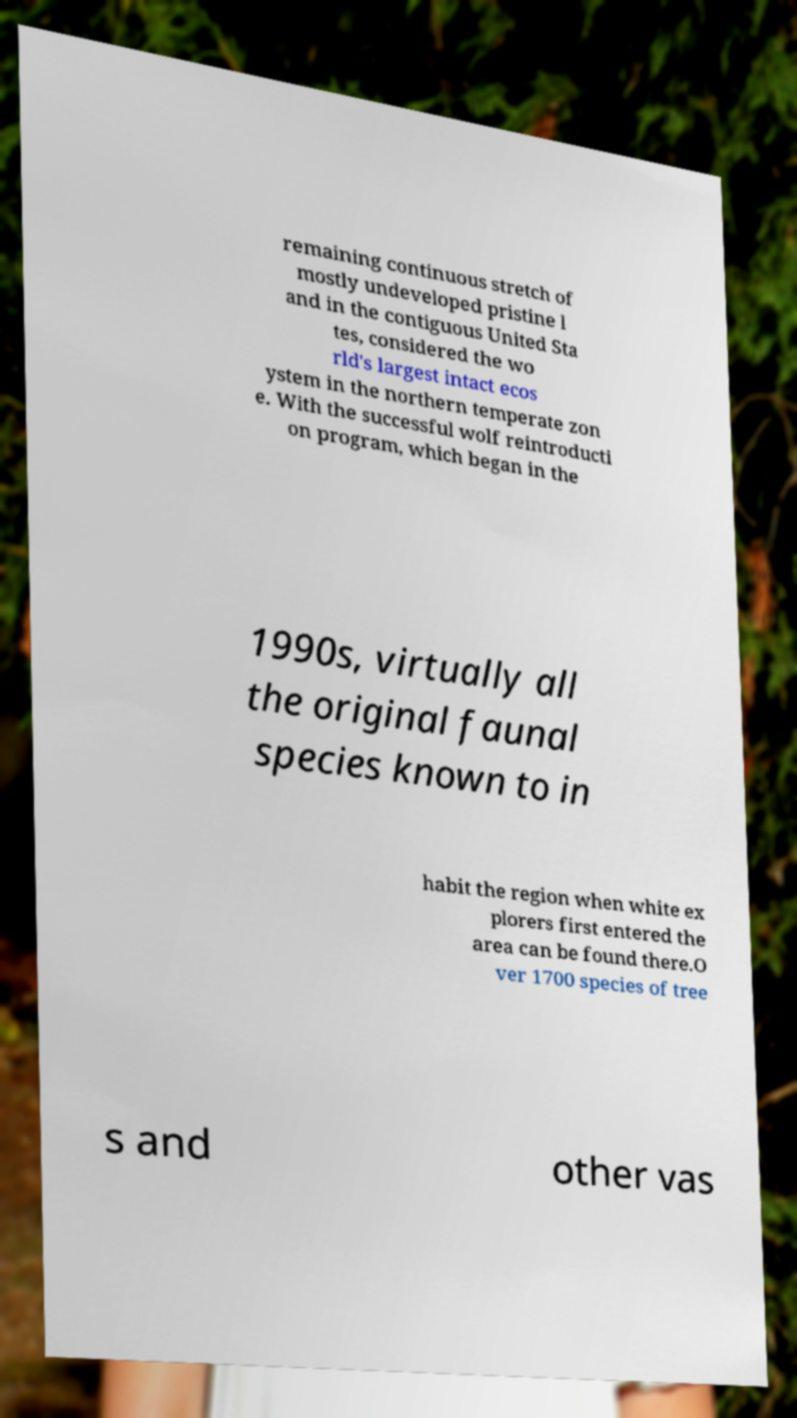Could you assist in decoding the text presented in this image and type it out clearly? remaining continuous stretch of mostly undeveloped pristine l and in the contiguous United Sta tes, considered the wo rld's largest intact ecos ystem in the northern temperate zon e. With the successful wolf reintroducti on program, which began in the 1990s, virtually all the original faunal species known to in habit the region when white ex plorers first entered the area can be found there.O ver 1700 species of tree s and other vas 